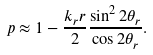<formula> <loc_0><loc_0><loc_500><loc_500>p \approx 1 - \frac { k _ { r } r } { 2 } \frac { \sin ^ { 2 } 2 \theta _ { r } } { \cos 2 \theta _ { r } } .</formula> 